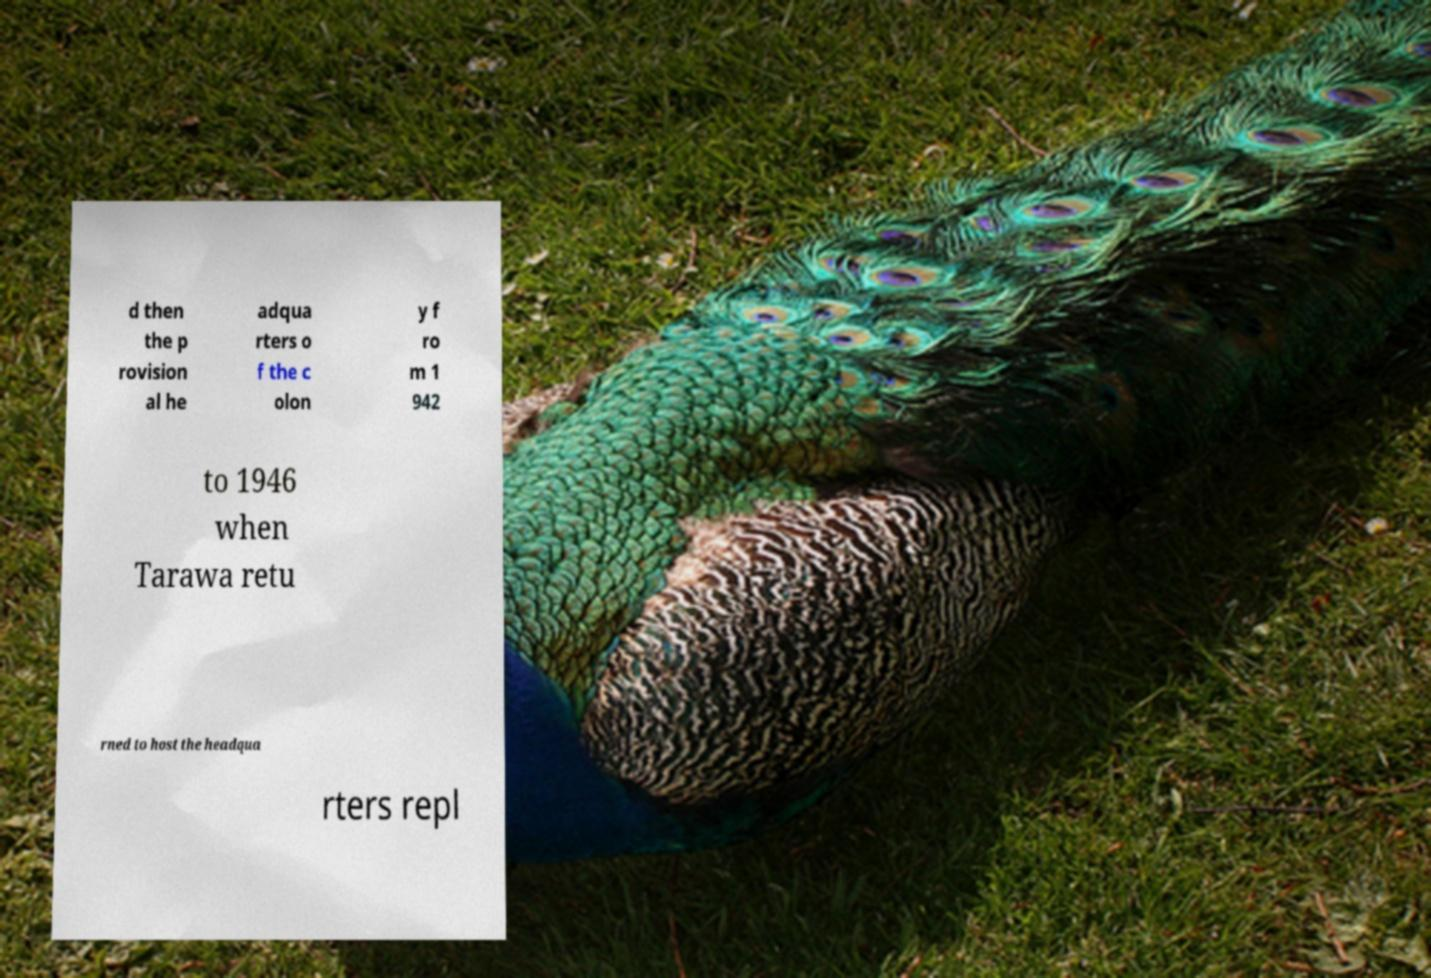What messages or text are displayed in this image? I need them in a readable, typed format. d then the p rovision al he adqua rters o f the c olon y f ro m 1 942 to 1946 when Tarawa retu rned to host the headqua rters repl 